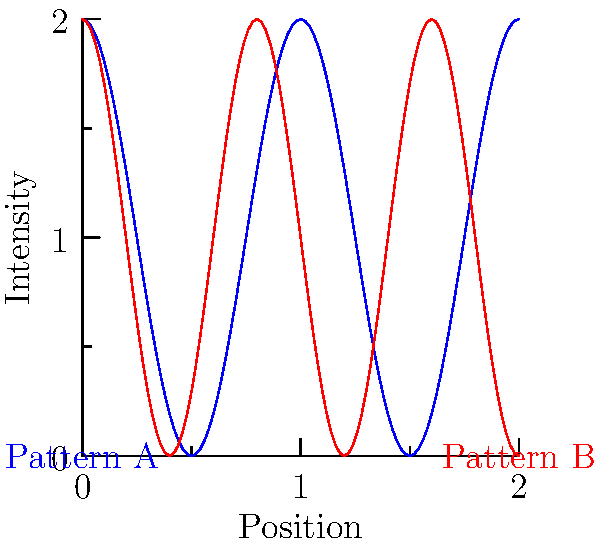In a double-slit experiment simulation, two interference patterns are observed as shown in the graph. Which pattern corresponds to a larger slit separation? To determine which pattern corresponds to a larger slit separation, we need to analyze the interference patterns:

1. In a double-slit experiment, the interference pattern is described by the equation:

   $$\Delta y = \frac{\lambda L}{d}$$

   where $\Delta y$ is the fringe spacing, $\lambda$ is the wavelength, $L$ is the distance to the screen, and $d$ is the slit separation.

2. From this equation, we can see that the fringe spacing $\Delta y$ is inversely proportional to the slit separation $d$.

3. Observing the graph:
   - Pattern A (blue) has wider fringes (larger $\Delta y$)
   - Pattern B (red) has narrower fringes (smaller $\Delta y$)

4. Since $\Delta y$ is inversely proportional to $d$, we can conclude:
   - Pattern A (wider fringes) corresponds to a smaller slit separation
   - Pattern B (narrower fringes) corresponds to a larger slit separation

5. Therefore, Pattern B corresponds to a larger slit separation.
Answer: Pattern B 